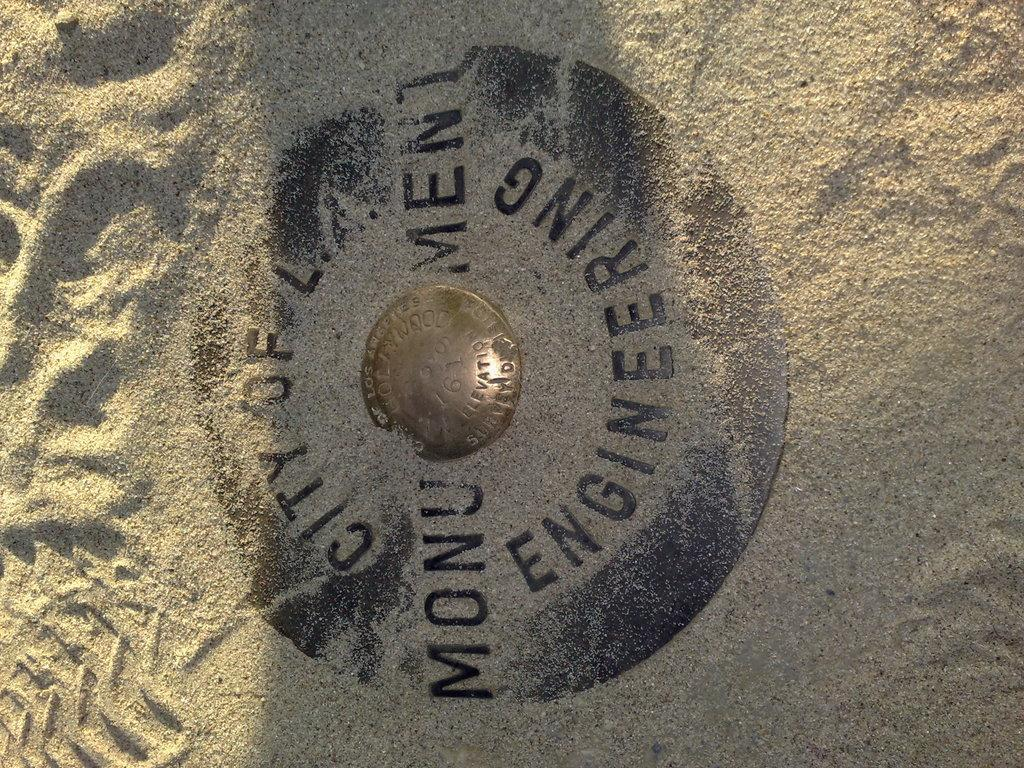<image>
Offer a succinct explanation of the picture presented. A metal plaque in the sand with monument engineering written on it. 